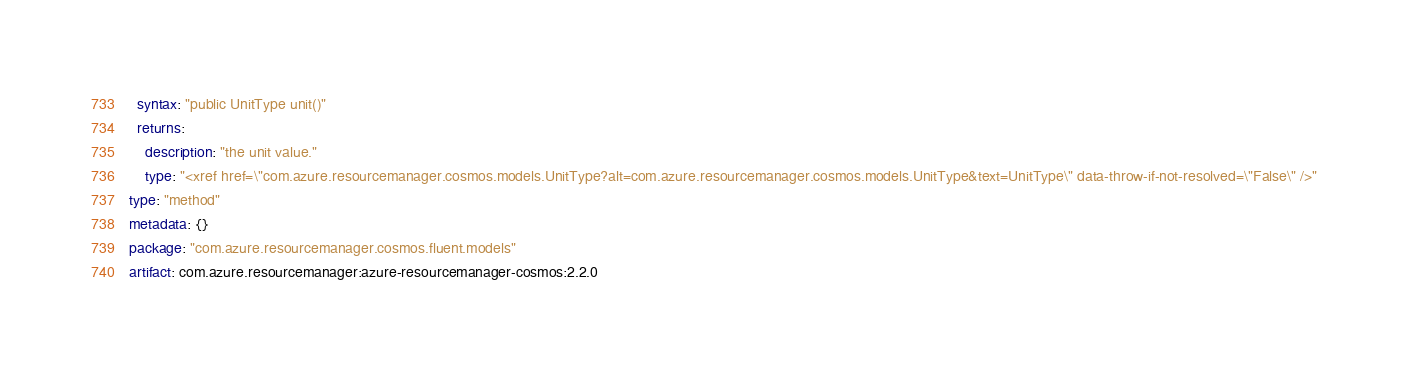Convert code to text. <code><loc_0><loc_0><loc_500><loc_500><_YAML_>  syntax: "public UnitType unit()"
  returns:
    description: "the unit value."
    type: "<xref href=\"com.azure.resourcemanager.cosmos.models.UnitType?alt=com.azure.resourcemanager.cosmos.models.UnitType&text=UnitType\" data-throw-if-not-resolved=\"False\" />"
type: "method"
metadata: {}
package: "com.azure.resourcemanager.cosmos.fluent.models"
artifact: com.azure.resourcemanager:azure-resourcemanager-cosmos:2.2.0
</code> 